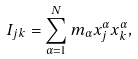<formula> <loc_0><loc_0><loc_500><loc_500>I _ { j k } = \sum _ { \alpha = 1 } ^ { N } m _ { \alpha } x _ { j } ^ { \alpha } x _ { k } ^ { \alpha } ,</formula> 